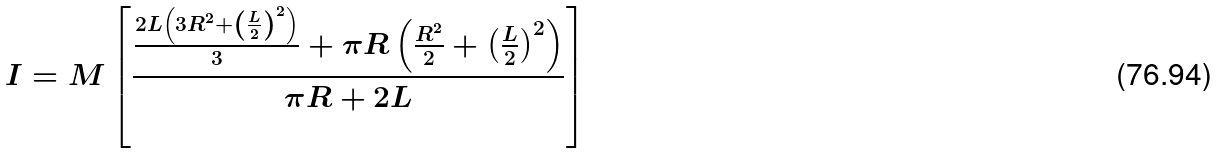Convert formula to latex. <formula><loc_0><loc_0><loc_500><loc_500>I = M \left [ \frac { \frac { 2 L \left ( 3 R ^ { 2 } + \left ( \frac { L } { 2 } \right ) ^ { 2 } \right ) } { 3 } + \pi R \left ( \frac { R ^ { 2 } } { 2 } + \left ( \frac { L } { 2 } \right ) ^ { 2 } \right ) } { \pi R + 2 L } \right ]</formula> 